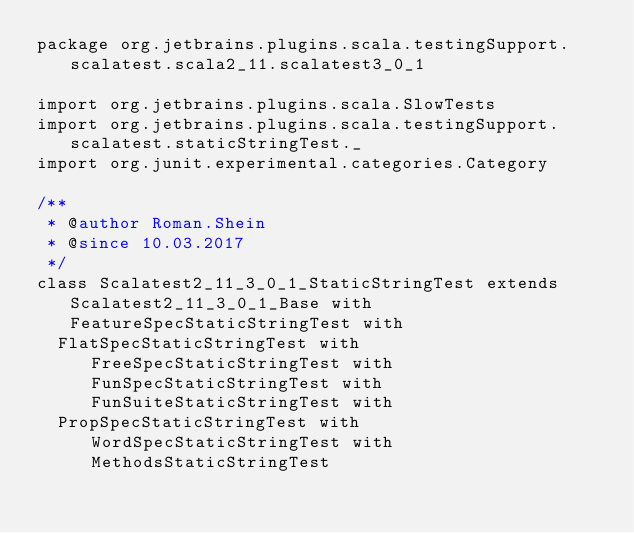<code> <loc_0><loc_0><loc_500><loc_500><_Scala_>package org.jetbrains.plugins.scala.testingSupport.scalatest.scala2_11.scalatest3_0_1

import org.jetbrains.plugins.scala.SlowTests
import org.jetbrains.plugins.scala.testingSupport.scalatest.staticStringTest._
import org.junit.experimental.categories.Category

/**
 * @author Roman.Shein
 * @since 10.03.2017
 */
class Scalatest2_11_3_0_1_StaticStringTest extends Scalatest2_11_3_0_1_Base with FeatureSpecStaticStringTest with
  FlatSpecStaticStringTest with FreeSpecStaticStringTest with FunSpecStaticStringTest with FunSuiteStaticStringTest with
  PropSpecStaticStringTest with WordSpecStaticStringTest with MethodsStaticStringTest
</code> 